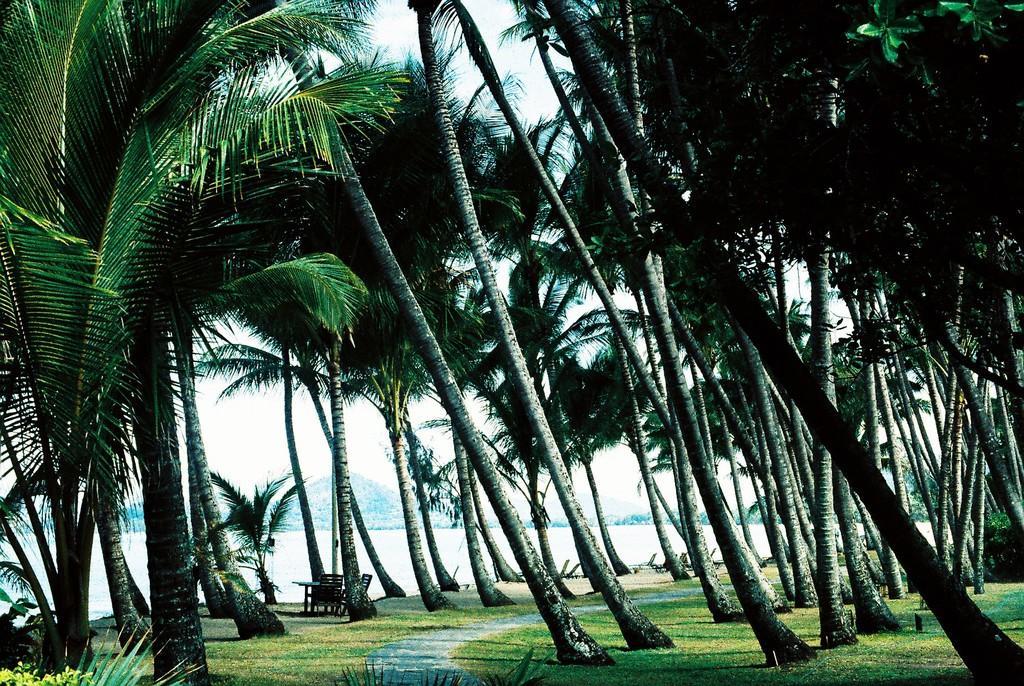Can you describe this image briefly? In this image there are some trees in middle of this image and there is a ground in the bottom of this image. There is a Sea as we can see from the bottom left side of this image ,and there is a sky in the background. 